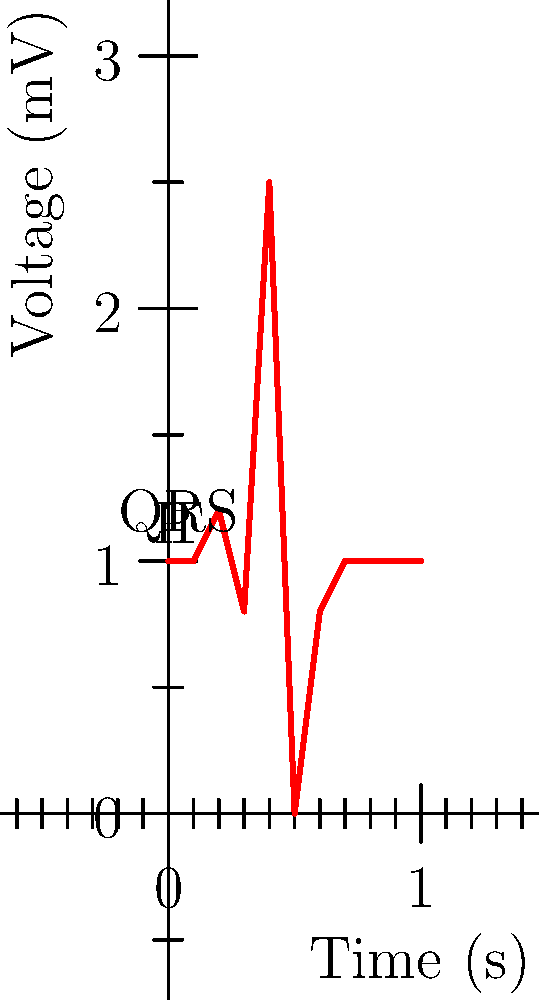In the ECG waveform shown above, which component represents ventricular depolarization and is crucial for assessing heart rhythm abnormalities in your medical documentary about women's cardiovascular health? To answer this question, let's break down the components of a typical ECG waveform:

1. The P wave represents atrial depolarization.
2. The QRS complex represents ventricular depolarization.
3. The T wave represents ventricular repolarization.

In the given ECG:
- The small upward deflection at the beginning is the P wave.
- The tall, narrow spike in the middle is the QRS complex.
- The smaller upward deflection after the QRS complex is the T wave.

The QRS complex is crucial for assessing heart rhythm abnormalities because:

1. It represents ventricular depolarization, which is the electrical activity that causes the ventricles to contract and pump blood.
2. Its duration, amplitude, and morphology can indicate various cardiac conditions.
3. Abnormalities in the QRS complex can suggest issues like ventricular hypertrophy, bundle branch blocks, or ventricular arrhythmias.

For a medical documentary about women's cardiovascular health, understanding the QRS complex is essential as it can help identify gender-specific differences in heart rhythms and potential cardiac issues more prevalent in women.
Answer: QRS complex 